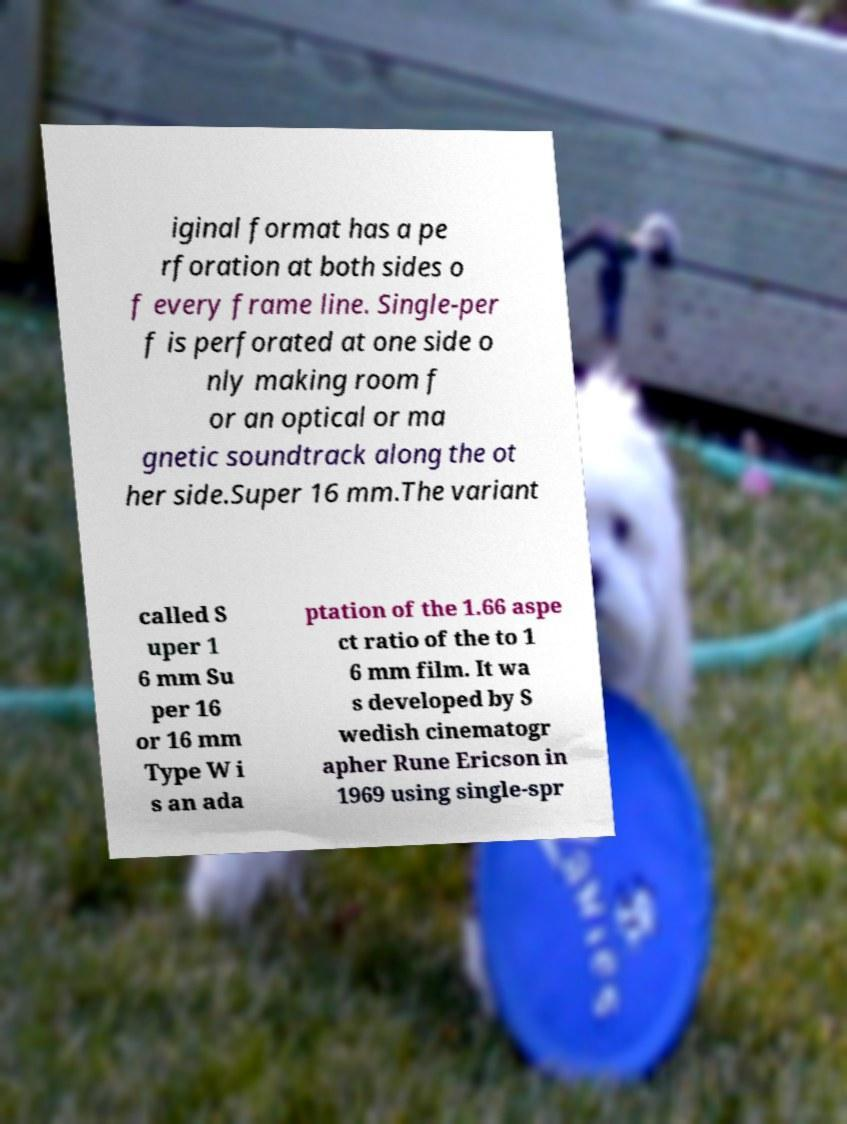Can you read and provide the text displayed in the image?This photo seems to have some interesting text. Can you extract and type it out for me? iginal format has a pe rforation at both sides o f every frame line. Single-per f is perforated at one side o nly making room f or an optical or ma gnetic soundtrack along the ot her side.Super 16 mm.The variant called S uper 1 6 mm Su per 16 or 16 mm Type W i s an ada ptation of the 1.66 aspe ct ratio of the to 1 6 mm film. It wa s developed by S wedish cinematogr apher Rune Ericson in 1969 using single-spr 